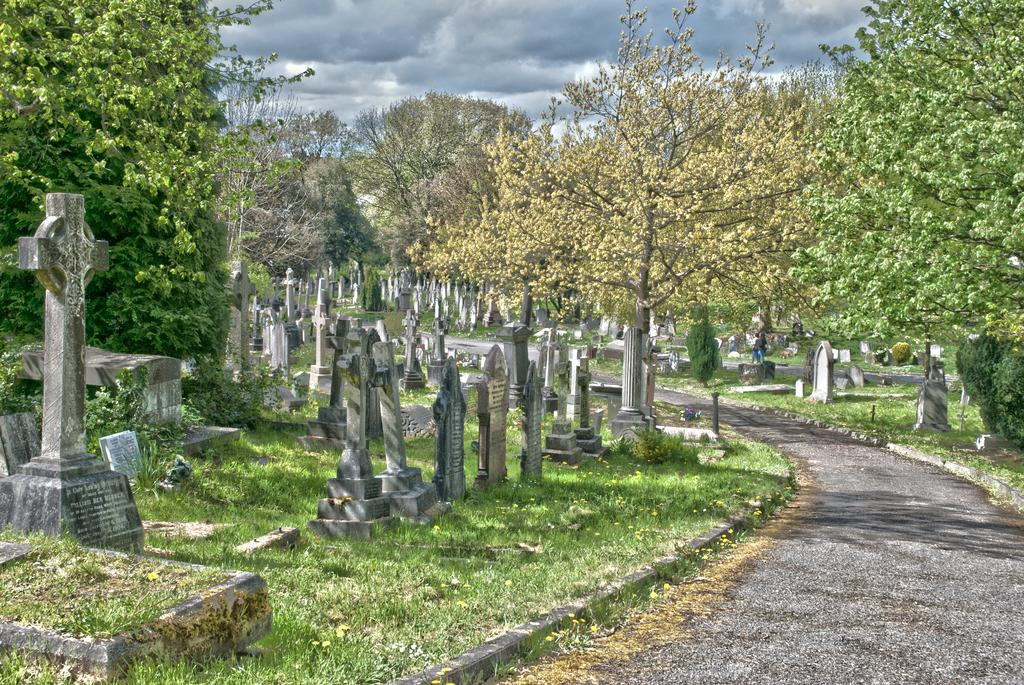What type of vegetation can be seen in the image? There are trees and plants in the image. What is the ground covered with in the image? There is grass in the image. What type of structures are present in the image? There are memorial stones in the image. How would you describe the sky in the image? The sky is cloudy in the image. Can you tell me how many zebras are grazing on the grass in the image? There are no zebras present in the image; it features trees, plants, memorial stones, and grass. What type of kitchen appliance can be seen near the memorial stones in the image? There is no kitchen appliance, such as a kettle, present in the image. 